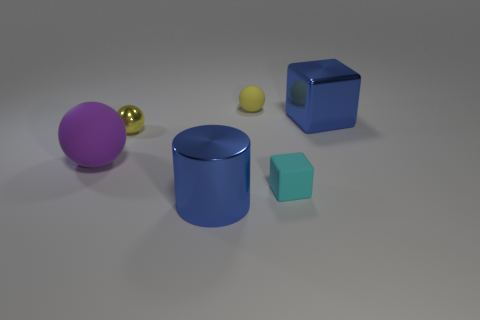Is the number of tiny blocks in front of the tiny matte sphere greater than the number of big cubes on the left side of the purple sphere?
Keep it short and to the point. Yes. What is the shape of the small object that is behind the small matte block and on the right side of the blue shiny cylinder?
Your answer should be compact. Sphere. There is a tiny thing in front of the tiny yellow metallic sphere; what is its shape?
Give a very brief answer. Cube. How big is the yellow sphere that is behind the small ball that is to the left of the small sphere behind the shiny sphere?
Your response must be concise. Small. Is the shape of the purple matte object the same as the tiny yellow metal thing?
Make the answer very short. Yes. What is the size of the thing that is both to the right of the blue metal cylinder and in front of the large purple thing?
Ensure brevity in your answer.  Small. There is another small yellow thing that is the same shape as the yellow matte object; what material is it?
Ensure brevity in your answer.  Metal. What material is the small yellow ball that is behind the big metal object on the right side of the cyan cube?
Your response must be concise. Rubber. There is a big purple thing; does it have the same shape as the big blue shiny object that is behind the blue metal cylinder?
Your response must be concise. No. How many metal things are big purple things or big gray cylinders?
Your response must be concise. 0. 